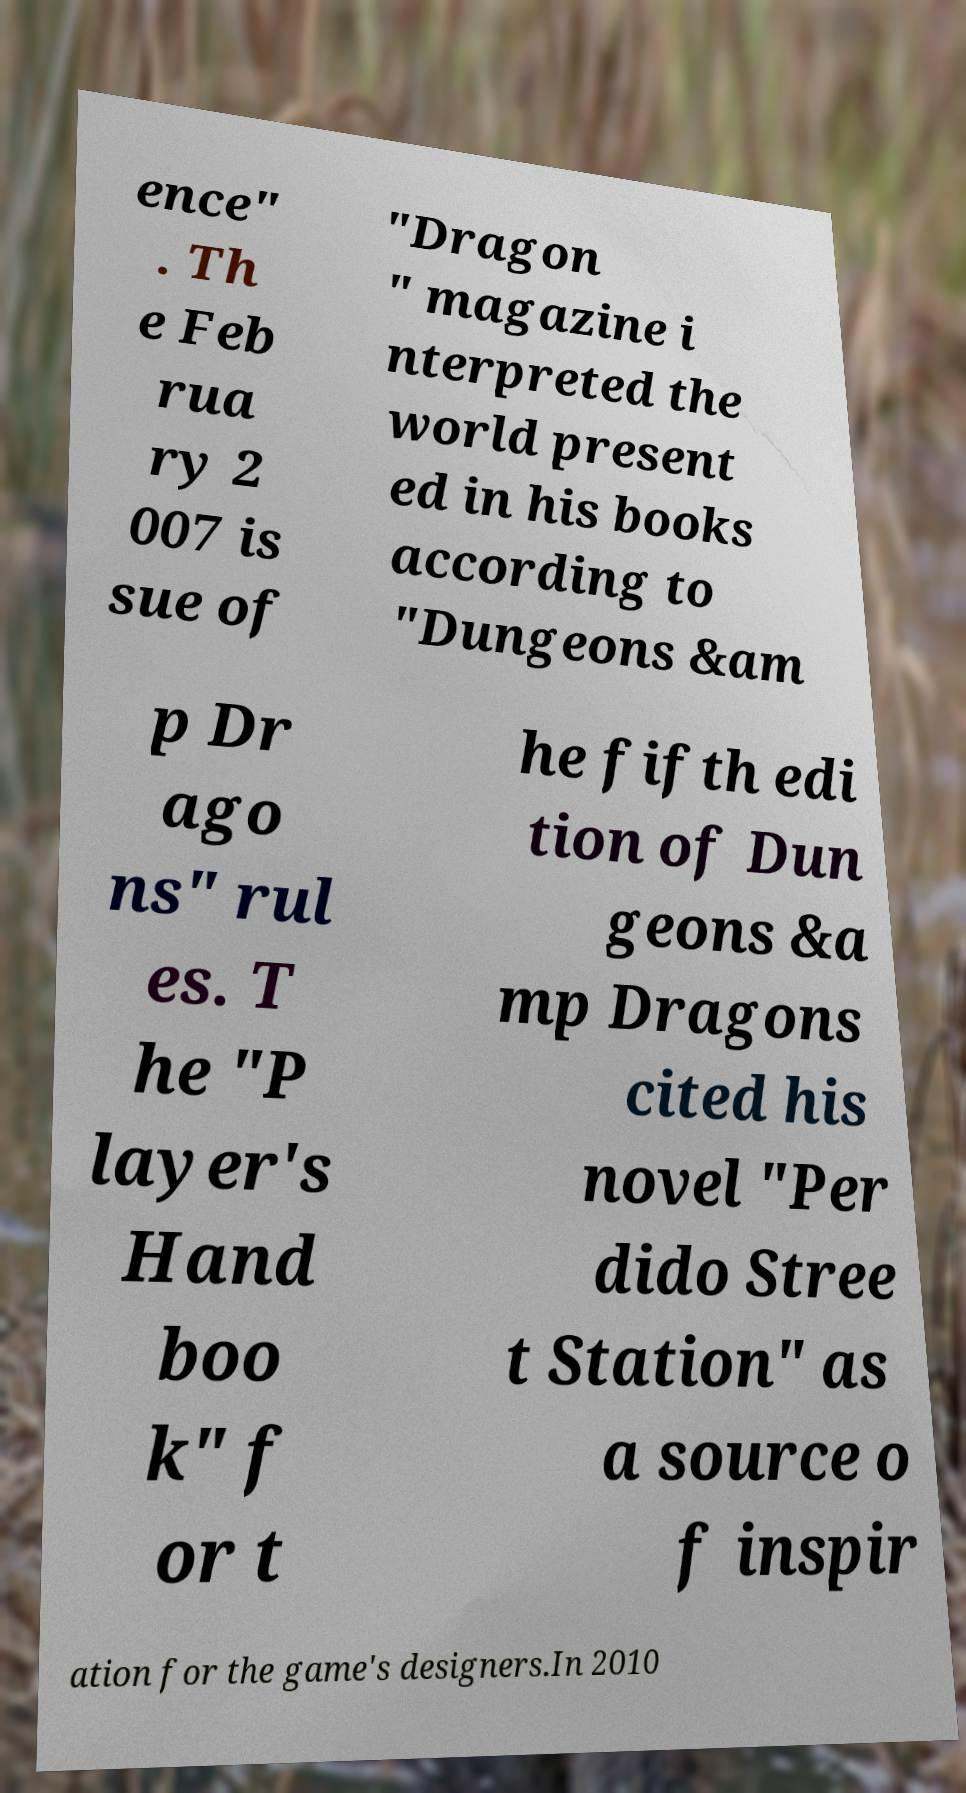Please identify and transcribe the text found in this image. ence" . Th e Feb rua ry 2 007 is sue of "Dragon " magazine i nterpreted the world present ed in his books according to "Dungeons &am p Dr ago ns" rul es. T he "P layer's Hand boo k" f or t he fifth edi tion of Dun geons &a mp Dragons cited his novel "Per dido Stree t Station" as a source o f inspir ation for the game's designers.In 2010 